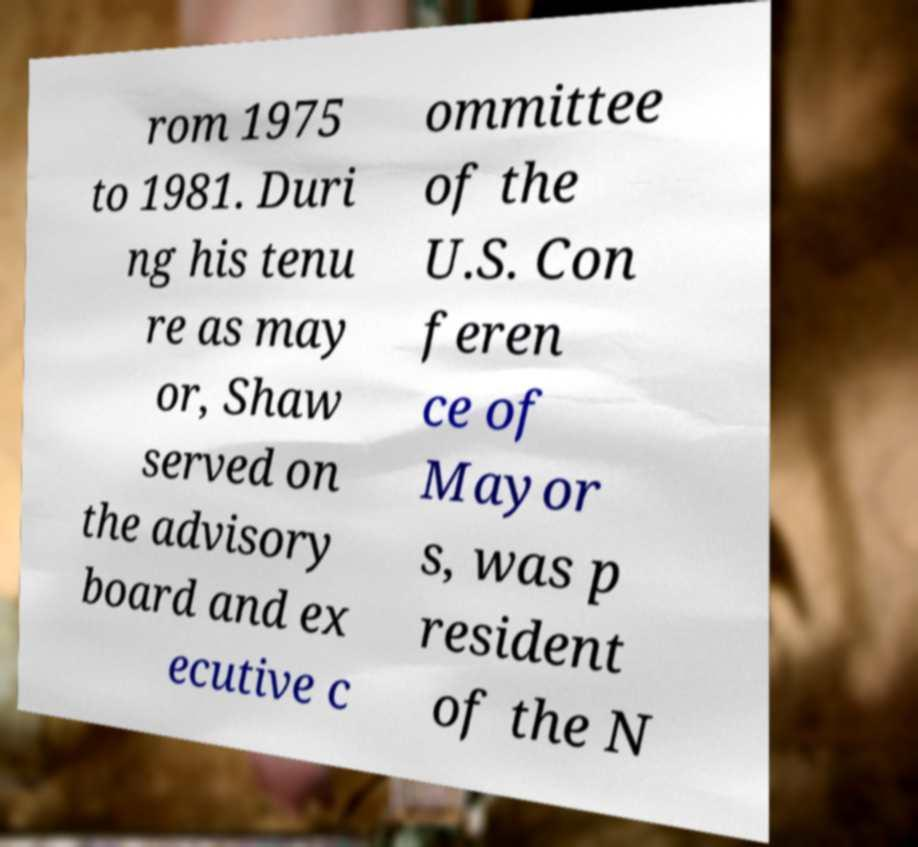For documentation purposes, I need the text within this image transcribed. Could you provide that? rom 1975 to 1981. Duri ng his tenu re as may or, Shaw served on the advisory board and ex ecutive c ommittee of the U.S. Con feren ce of Mayor s, was p resident of the N 